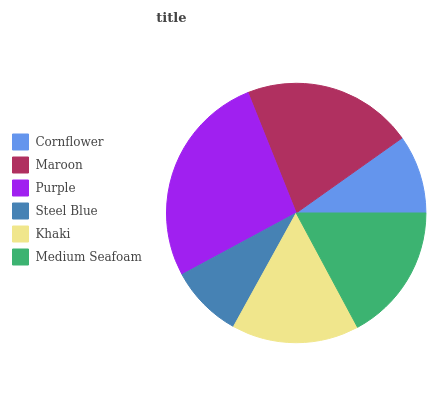Is Steel Blue the minimum?
Answer yes or no. Yes. Is Purple the maximum?
Answer yes or no. Yes. Is Maroon the minimum?
Answer yes or no. No. Is Maroon the maximum?
Answer yes or no. No. Is Maroon greater than Cornflower?
Answer yes or no. Yes. Is Cornflower less than Maroon?
Answer yes or no. Yes. Is Cornflower greater than Maroon?
Answer yes or no. No. Is Maroon less than Cornflower?
Answer yes or no. No. Is Medium Seafoam the high median?
Answer yes or no. Yes. Is Khaki the low median?
Answer yes or no. Yes. Is Maroon the high median?
Answer yes or no. No. Is Cornflower the low median?
Answer yes or no. No. 